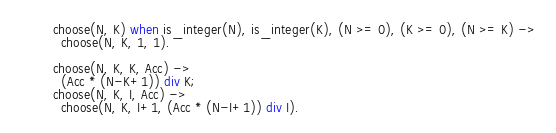<code> <loc_0><loc_0><loc_500><loc_500><_Erlang_>choose(N, K) when is_integer(N), is_integer(K), (N >= 0), (K >= 0), (N >= K) ->
  choose(N, K, 1, 1).

choose(N, K, K, Acc) ->
  (Acc * (N-K+1)) div K;
choose(N, K, I, Acc) ->
  choose(N, K, I+1, (Acc * (N-I+1)) div I).
</code> 